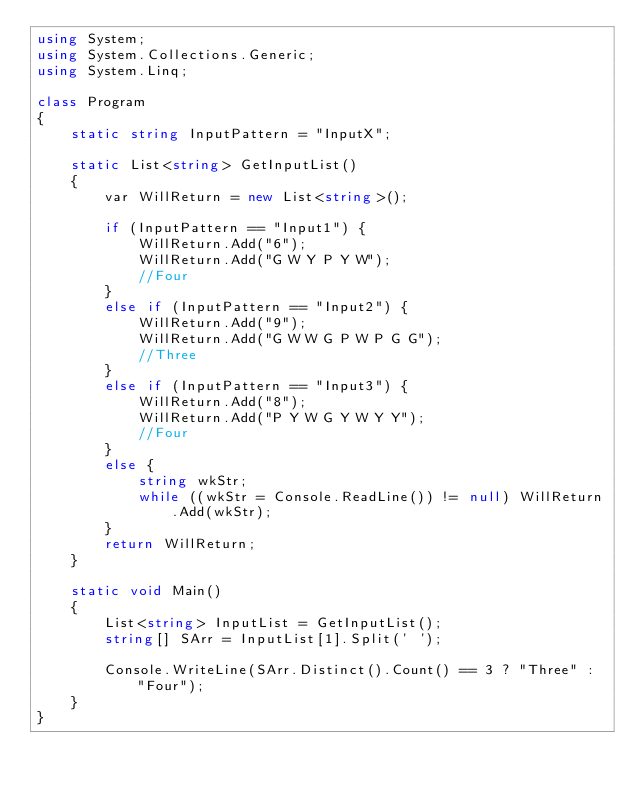<code> <loc_0><loc_0><loc_500><loc_500><_C#_>using System;
using System.Collections.Generic;
using System.Linq;

class Program
{
    static string InputPattern = "InputX";

    static List<string> GetInputList()
    {
        var WillReturn = new List<string>();

        if (InputPattern == "Input1") {
            WillReturn.Add("6");
            WillReturn.Add("G W Y P Y W");
            //Four
        }
        else if (InputPattern == "Input2") {
            WillReturn.Add("9");
            WillReturn.Add("G W W G P W P G G");
            //Three
        }
        else if (InputPattern == "Input3") {
            WillReturn.Add("8");
            WillReturn.Add("P Y W G Y W Y Y");
            //Four
        }
        else {
            string wkStr;
            while ((wkStr = Console.ReadLine()) != null) WillReturn.Add(wkStr);
        }
        return WillReturn;
    }

    static void Main()
    {
        List<string> InputList = GetInputList();
        string[] SArr = InputList[1].Split(' ');

        Console.WriteLine(SArr.Distinct().Count() == 3 ? "Three" : "Four");
    }
}
</code> 